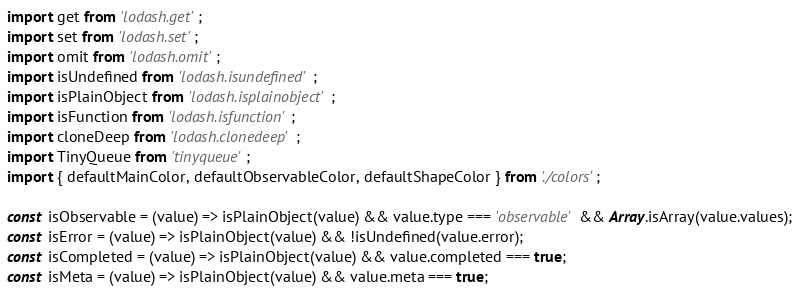<code> <loc_0><loc_0><loc_500><loc_500><_JavaScript_>import get from 'lodash.get';
import set from 'lodash.set';
import omit from 'lodash.omit';
import isUndefined from 'lodash.isundefined';
import isPlainObject from 'lodash.isplainobject';
import isFunction from 'lodash.isfunction';
import cloneDeep from 'lodash.clonedeep';
import TinyQueue from 'tinyqueue';
import { defaultMainColor, defaultObservableColor, defaultShapeColor } from './colors';

const isObservable = (value) => isPlainObject(value) && value.type === 'observable' && Array.isArray(value.values);
const isError = (value) => isPlainObject(value) && !isUndefined(value.error);
const isCompleted = (value) => isPlainObject(value) && value.completed === true;
const isMeta = (value) => isPlainObject(value) && value.meta === true;
</code> 